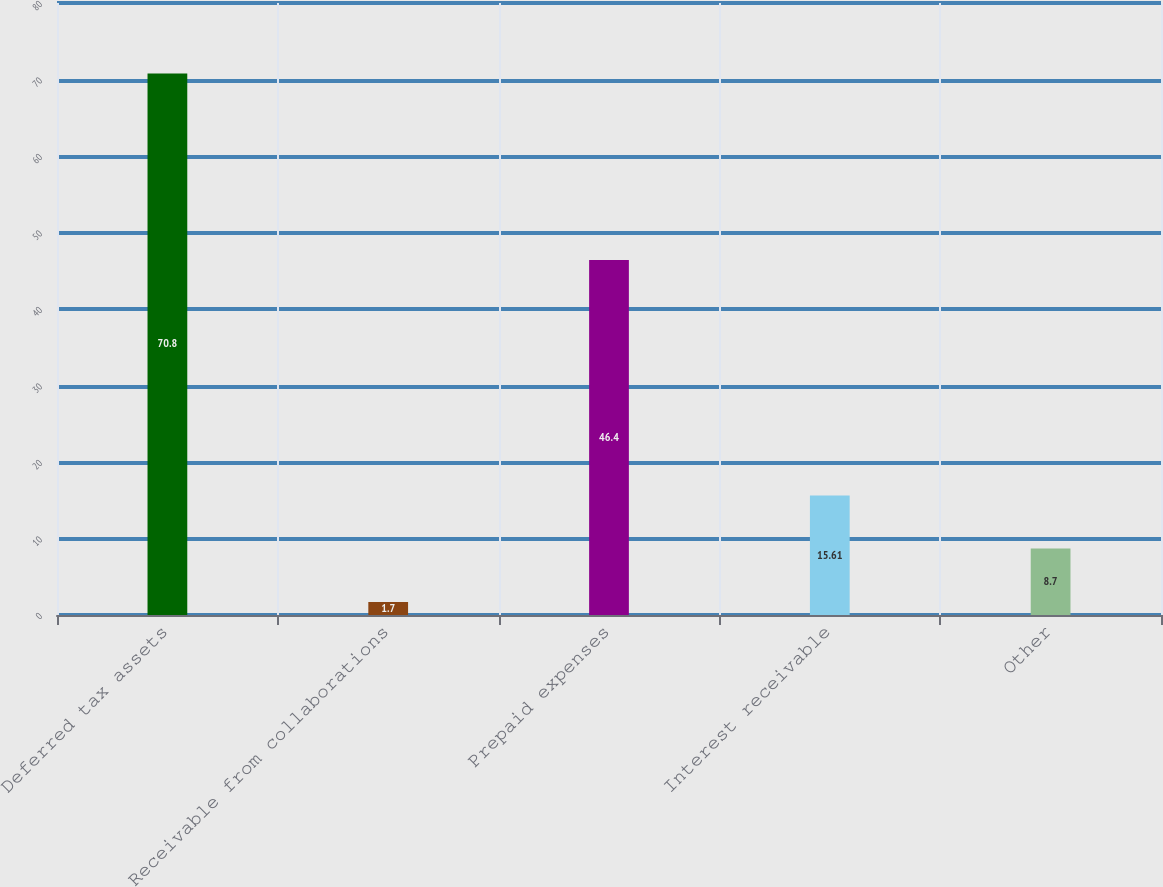Convert chart to OTSL. <chart><loc_0><loc_0><loc_500><loc_500><bar_chart><fcel>Deferred tax assets<fcel>Receivable from collaborations<fcel>Prepaid expenses<fcel>Interest receivable<fcel>Other<nl><fcel>70.8<fcel>1.7<fcel>46.4<fcel>15.61<fcel>8.7<nl></chart> 